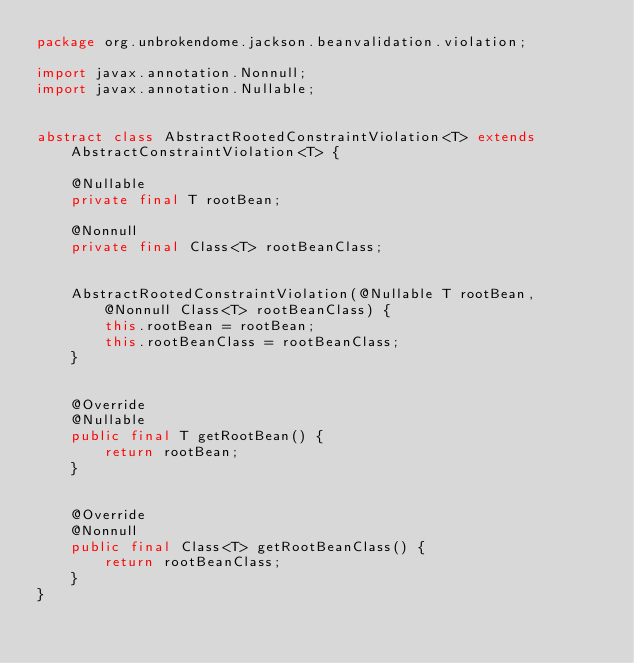Convert code to text. <code><loc_0><loc_0><loc_500><loc_500><_Java_>package org.unbrokendome.jackson.beanvalidation.violation;

import javax.annotation.Nonnull;
import javax.annotation.Nullable;


abstract class AbstractRootedConstraintViolation<T> extends AbstractConstraintViolation<T> {

    @Nullable
    private final T rootBean;

    @Nonnull
    private final Class<T> rootBeanClass;


    AbstractRootedConstraintViolation(@Nullable T rootBean, @Nonnull Class<T> rootBeanClass) {
        this.rootBean = rootBean;
        this.rootBeanClass = rootBeanClass;
    }


    @Override
    @Nullable
    public final T getRootBean() {
        return rootBean;
    }


    @Override
    @Nonnull
    public final Class<T> getRootBeanClass() {
        return rootBeanClass;
    }
}
</code> 